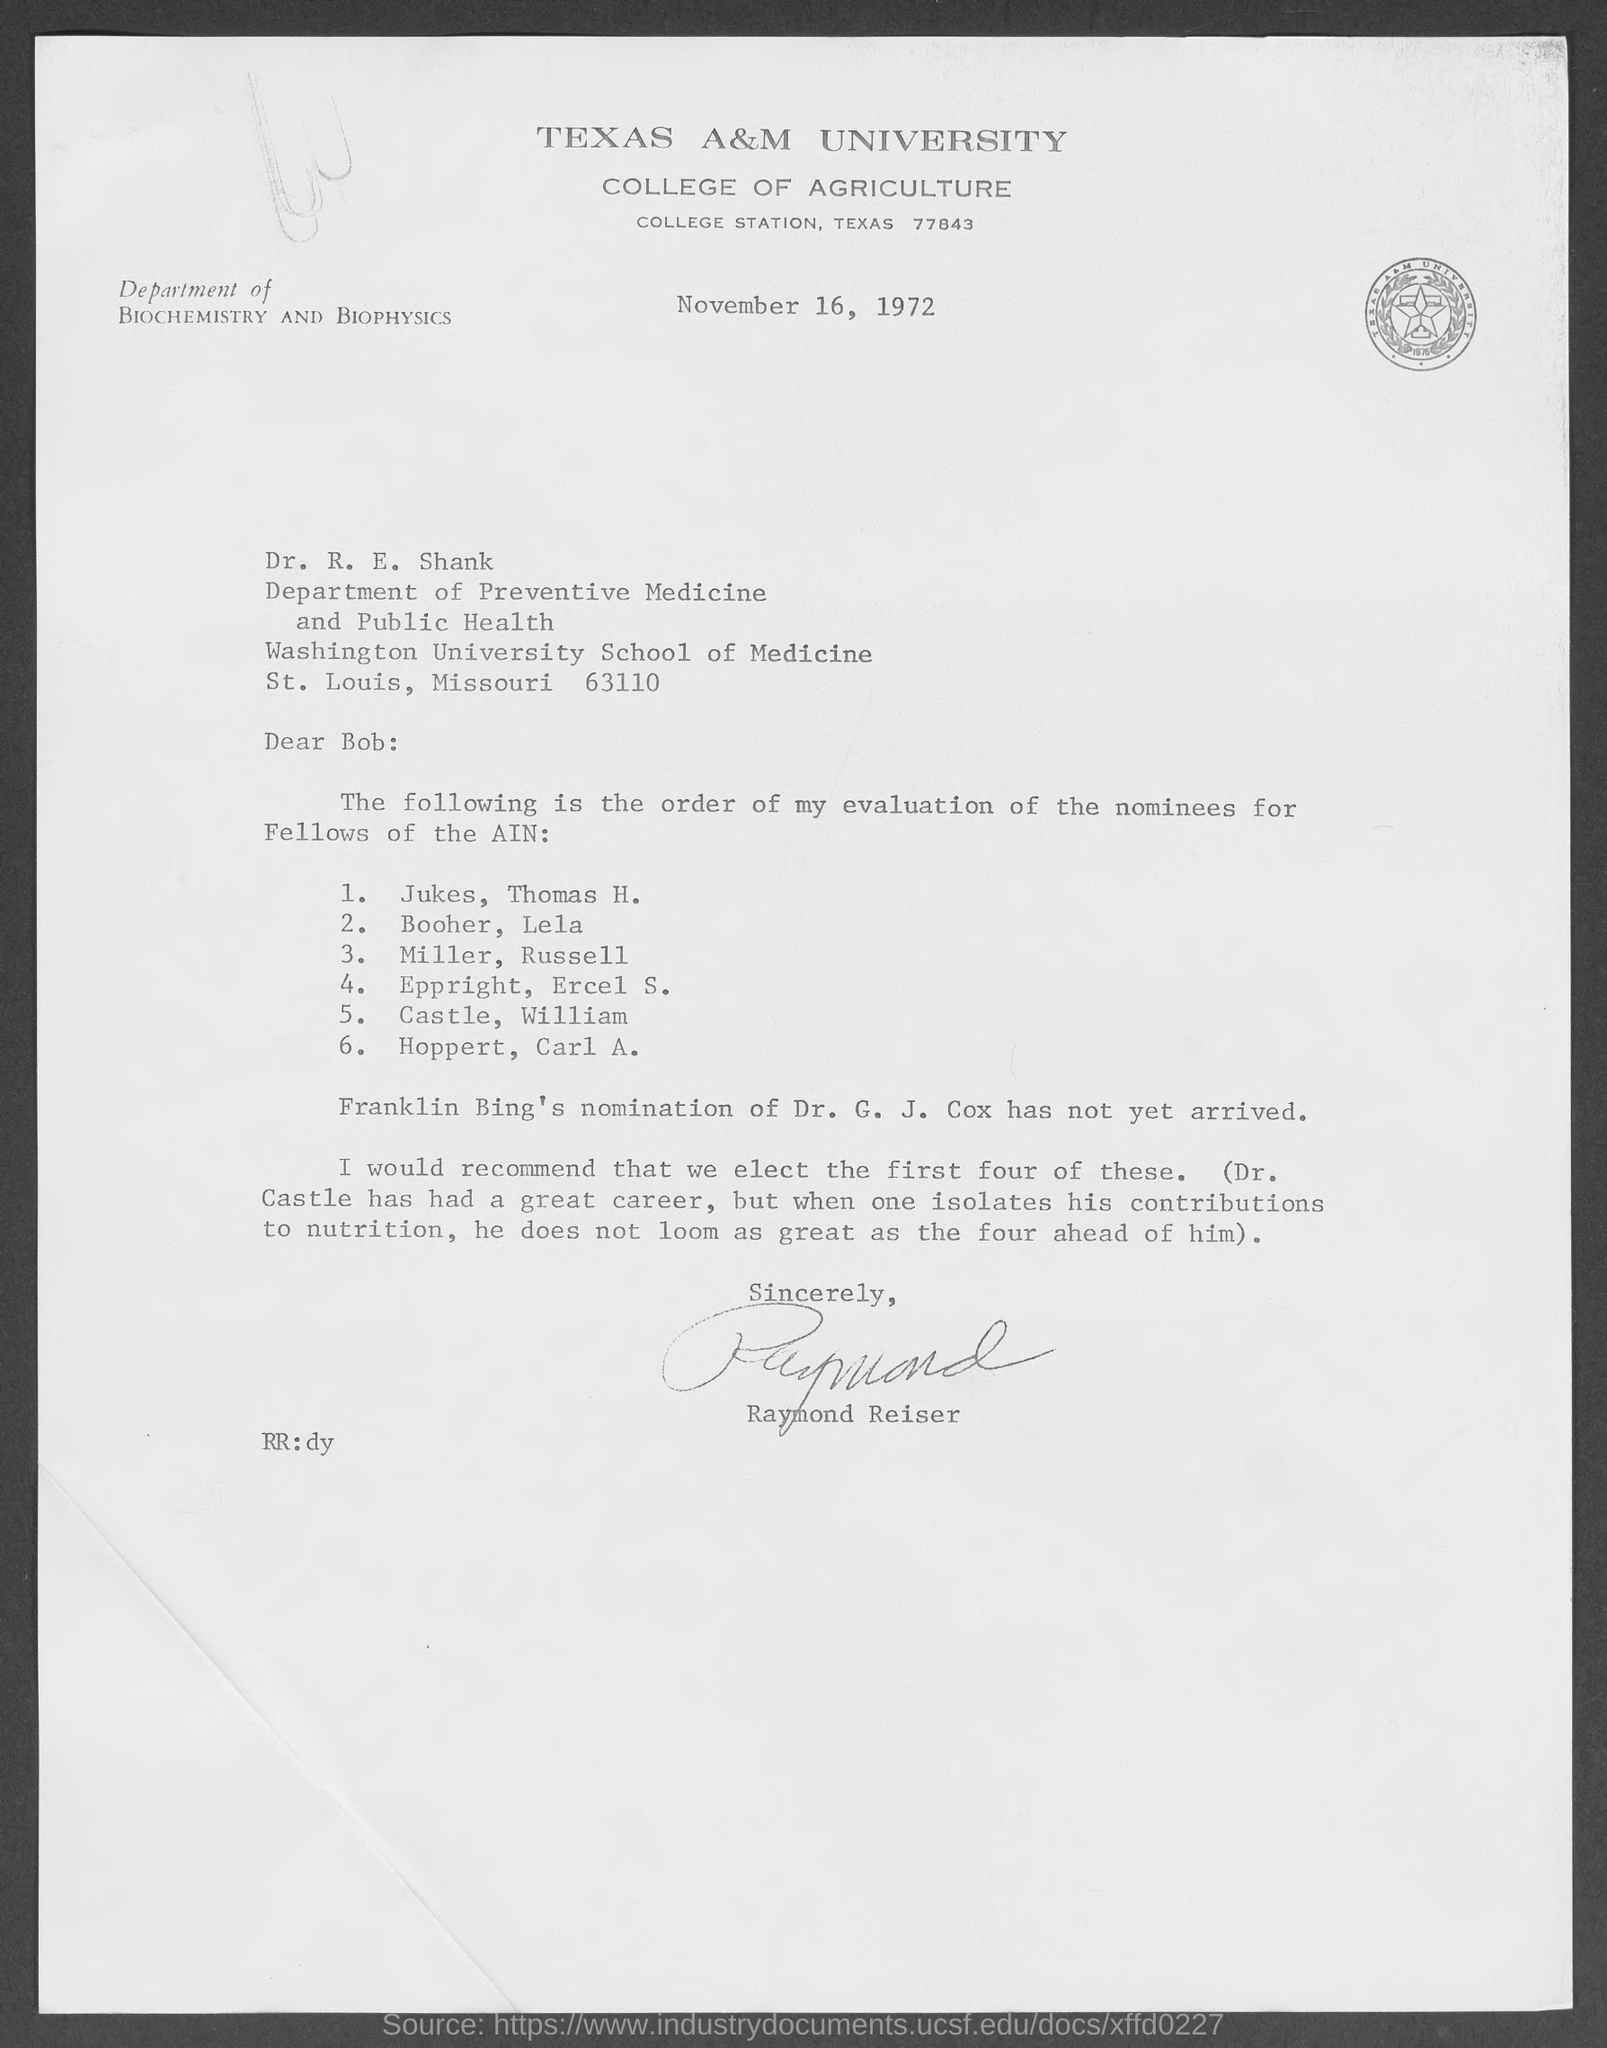What is the date?
Provide a succinct answer. November 16, 1972. What is the salutation of this letter?
Give a very brief answer. Dear Bob:. 